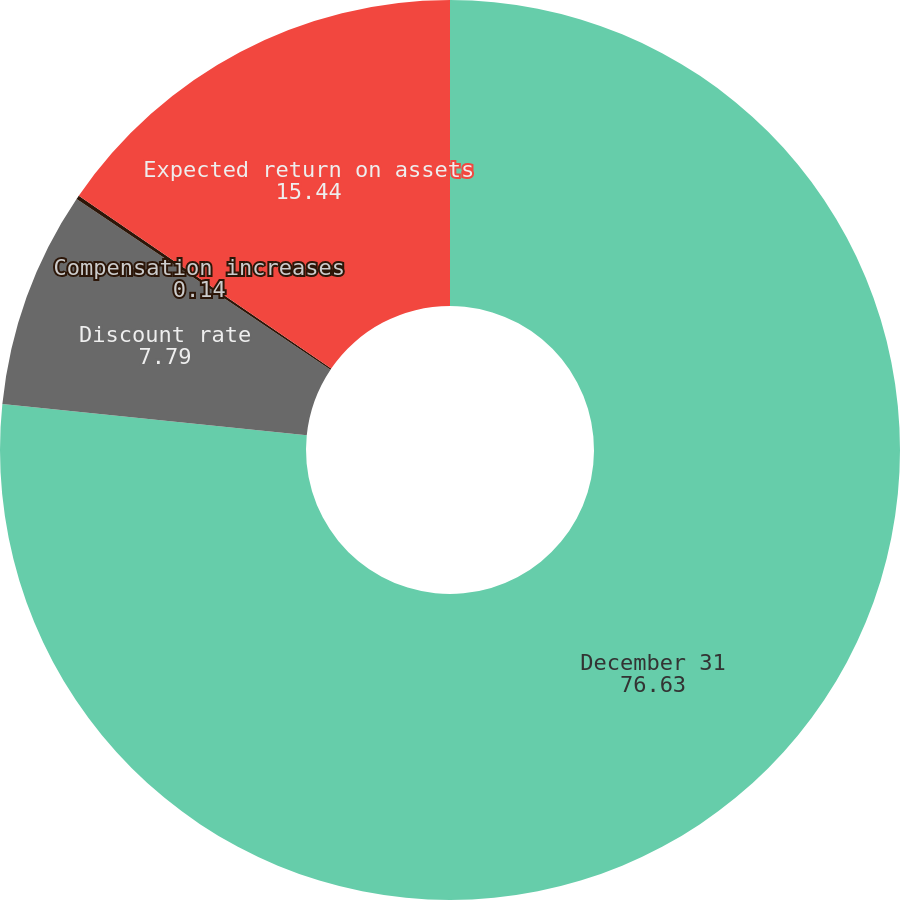Convert chart to OTSL. <chart><loc_0><loc_0><loc_500><loc_500><pie_chart><fcel>December 31<fcel>Discount rate<fcel>Compensation increases<fcel>Expected return on assets<nl><fcel>76.63%<fcel>7.79%<fcel>0.14%<fcel>15.44%<nl></chart> 